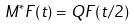<formula> <loc_0><loc_0><loc_500><loc_500>M ^ { * } F ( t ) = Q F ( t / 2 )</formula> 